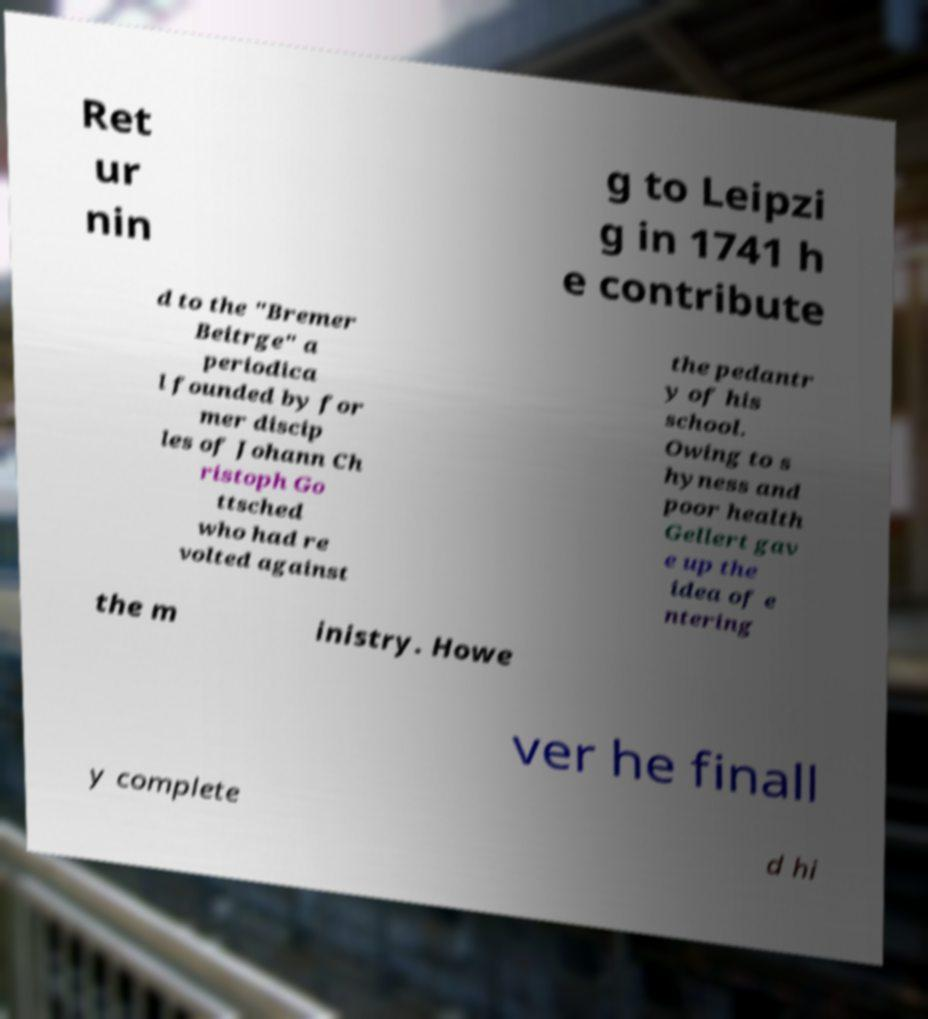Please identify and transcribe the text found in this image. Ret ur nin g to Leipzi g in 1741 h e contribute d to the "Bremer Beitrge" a periodica l founded by for mer discip les of Johann Ch ristoph Go ttsched who had re volted against the pedantr y of his school. Owing to s hyness and poor health Gellert gav e up the idea of e ntering the m inistry. Howe ver he finall y complete d hi 